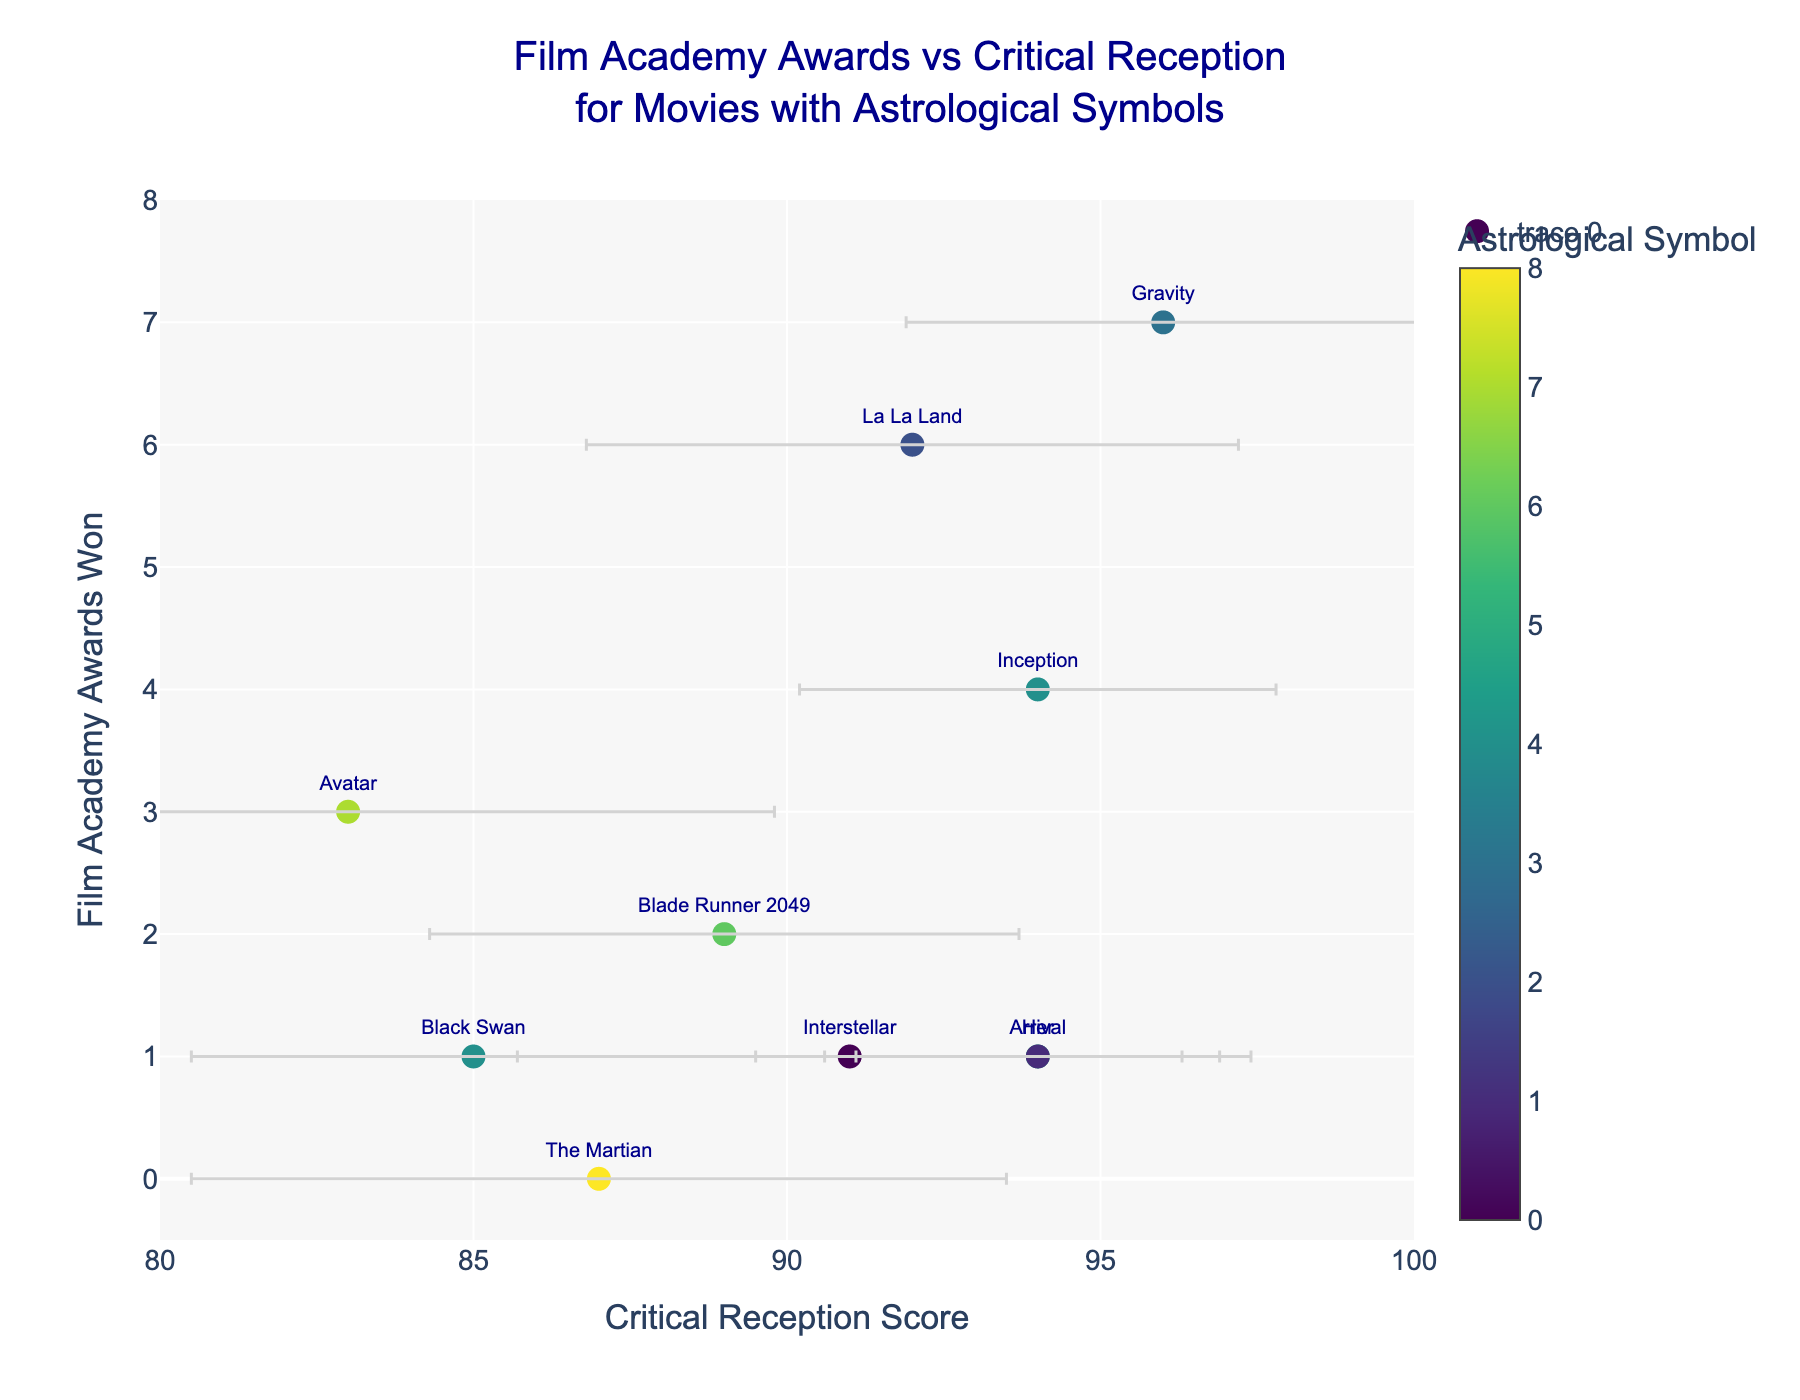What is the title of the figure? The title is at the top of the figure and summarizes what the graph represents.
Answer: Film Academy Awards vs Critical Reception for Movies with Astrological Symbols How many films have a Critical Reception Score of 94? Look at the x-axis for the value 94 and count the corresponding markers.
Answer: 3 Which film has the highest number of awards? Identify the highest y-axis value and refer to the text next to the marker at that point.
Answer: Gravity What is the Review Variance for "The Martian"? Locate "The Martian" on the plot and read the corresponding x-axis error bar length.
Answer: 6.5 Compare the number of awards won by "Inception" and "La La Land". Which one won more awards? Find "Inception" and "La La Land" on the y-axis and compare their values.
Answer: La La Land What is the range of Critical Reception Scores displayed in the figure? The minimum and maximum values on the x-axis define the range.
Answer: 83 to 96 Identify the film with the least number of awards and its Critical Reception Score. Find the marker closest to zero on the y-axis and note its x-axis value.
Answer: The Martian, 87 How many films have the astrological symbol Pisces? Look at the color bar representing astrological symbols and count the markers for Pisces.
Answer: 2 Which two films have the same Critical Reception Score of 94 but different astrological symbols? Locate the markers with the x-value of 94 and compare their hover texts and astrological symbols.
Answer: Her (Sagittarius) and Arrival (Gemini) What is the average number of awards won by films with a Critical Reception Score greater than 90? Identify the films with x-axis values over 90, sum their awards, and divide by the number of such films. (1 + 7 + 4 + 6 + 1 + 1) / 6 = 20 / 6 = 3.33
Answer: 3.33 